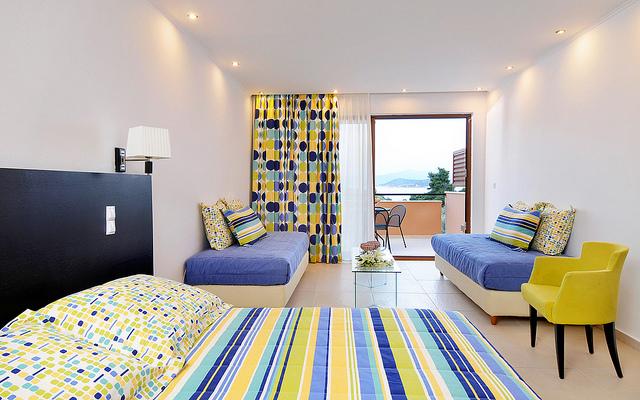What color is the lamp shade?
Short answer required. White. What are the primary colors in this decor?
Answer briefly. Yellow and blue. What pattern is on the drapes?
Give a very brief answer. Circles. Is it night time?
Concise answer only. No. What color is the chair in the foreground?
Quick response, please. Yellow. Might this be a motel/hotel?
Keep it brief. Yes. 